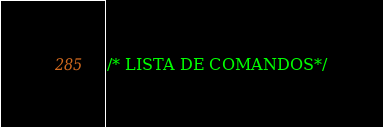Convert code to text. <code><loc_0><loc_0><loc_500><loc_500><_JavaScript_>/* LISTA DE COMANDOS*/</code> 